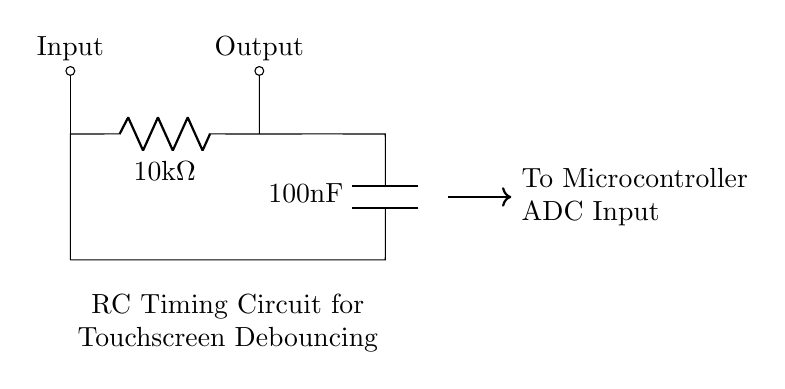What is the value of the resistor in this circuit? The resistor is labeled as R1 in the circuit. Its value is explicitly stated as 10 kΩ.
Answer: 10 kΩ What type of capacitor is used in this circuit? The capacitor is labeled as C1. The value is specified as 100 nF, indicating it is a standard capacitor used in timing applications.
Answer: 100 nF What is the purpose of this RC timing circuit? The circuit is designed to create a delay and debounce mechanism for touchscreen input, allowing for stable readings when the touch sensor is activated.
Answer: Debouncing What happens to the output signal when the input is applied? When the input is applied, the capacitor begins to charge through the resistor, which affects the timing of the output pulse and helps filter noise.
Answer: Delayed output What is the effect of increasing the resistor value on the timing of the circuit? Increasing the resistor value will lead to a longer charging time for the capacitor, resulting in a longer delay before the output signal changes state.
Answer: Longer delay How is the output connected to the microcontroller in this circuit? The output is taken from the node between the resistor and the capacitor and is connected to the microcontroller's ADC input, allowing for digital signal processing.
Answer: Connected to ADC input 